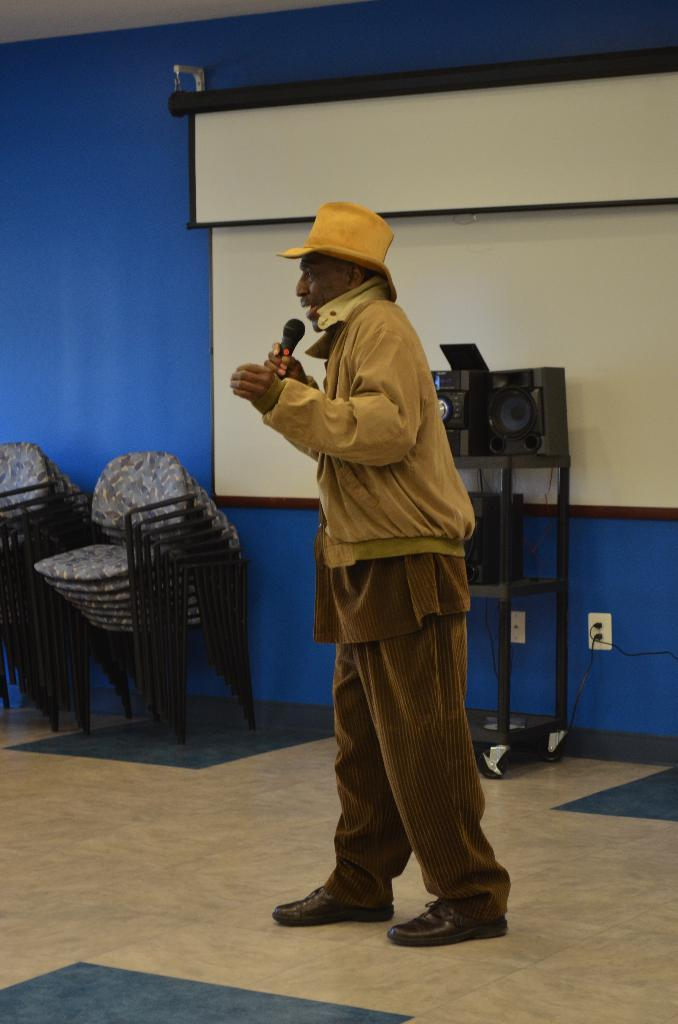What is the person in the image holding? The person is holding a mic. What color is the dress the person is wearing? The person is wearing a brown color dress. What type of furniture can be seen in the image? Chairs are visible in the image. What device is present for amplifying sound? There is a speaker in the image. What is the color of the screen in the image? The screen in the image is white color. What color is the wall in the image? The wall is blue color. Is there a veil covering the person's face in the image? No, there is no veil covering the person's face in the image. Can you see a string attached to the mic in the image? No, there is no string attached to the mic in the image. 